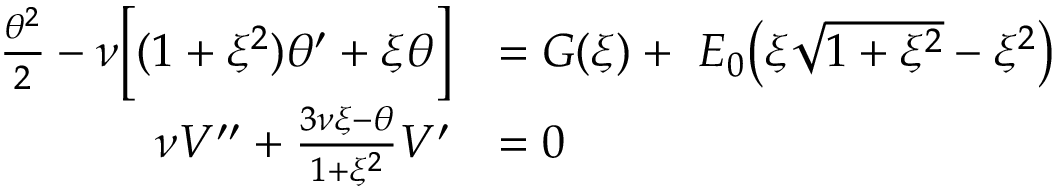<formula> <loc_0><loc_0><loc_500><loc_500>\begin{array} { r l } { \frac { \theta ^ { 2 } } { 2 } - \nu \left [ ( 1 + \xi ^ { 2 } ) \theta ^ { \prime } + \xi \theta \right ] } & { = G ( \xi ) + \, { E _ { 0 } } \left ( \xi \sqrt { 1 + \xi ^ { 2 } } - \xi ^ { 2 } \right ) } \\ { \nu V ^ { \prime \prime } + \frac { 3 \nu \xi - \theta } { 1 + \xi ^ { 2 } } V ^ { \prime } } & { = 0 } \end{array}</formula> 